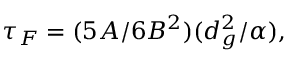<formula> <loc_0><loc_0><loc_500><loc_500>\tau _ { F } = ( { 5 A } / { 6 B ^ { 2 } } ) ( { d _ { g } ^ { 2 } } / { \alpha } ) ,</formula> 